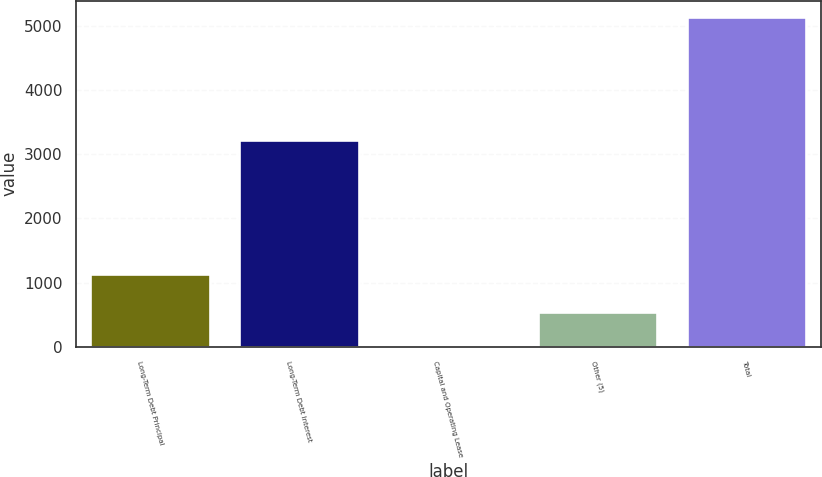Convert chart. <chart><loc_0><loc_0><loc_500><loc_500><bar_chart><fcel>Long-Term Debt Principal<fcel>Long-Term Debt Interest<fcel>Capital and Operating Lease<fcel>Other (5)<fcel>Total<nl><fcel>1129<fcel>3224<fcel>27<fcel>538.1<fcel>5138<nl></chart> 